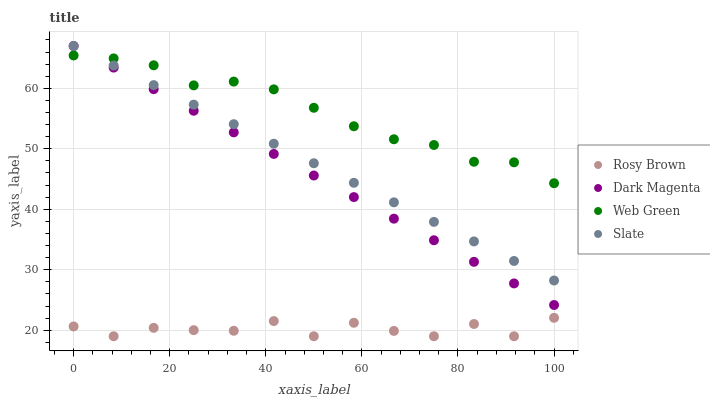Does Rosy Brown have the minimum area under the curve?
Answer yes or no. Yes. Does Web Green have the maximum area under the curve?
Answer yes or no. Yes. Does Dark Magenta have the minimum area under the curve?
Answer yes or no. No. Does Dark Magenta have the maximum area under the curve?
Answer yes or no. No. Is Dark Magenta the smoothest?
Answer yes or no. Yes. Is Rosy Brown the roughest?
Answer yes or no. Yes. Is Rosy Brown the smoothest?
Answer yes or no. No. Is Dark Magenta the roughest?
Answer yes or no. No. Does Rosy Brown have the lowest value?
Answer yes or no. Yes. Does Dark Magenta have the lowest value?
Answer yes or no. No. Does Dark Magenta have the highest value?
Answer yes or no. Yes. Does Rosy Brown have the highest value?
Answer yes or no. No. Is Rosy Brown less than Slate?
Answer yes or no. Yes. Is Web Green greater than Rosy Brown?
Answer yes or no. Yes. Does Slate intersect Web Green?
Answer yes or no. Yes. Is Slate less than Web Green?
Answer yes or no. No. Is Slate greater than Web Green?
Answer yes or no. No. Does Rosy Brown intersect Slate?
Answer yes or no. No. 